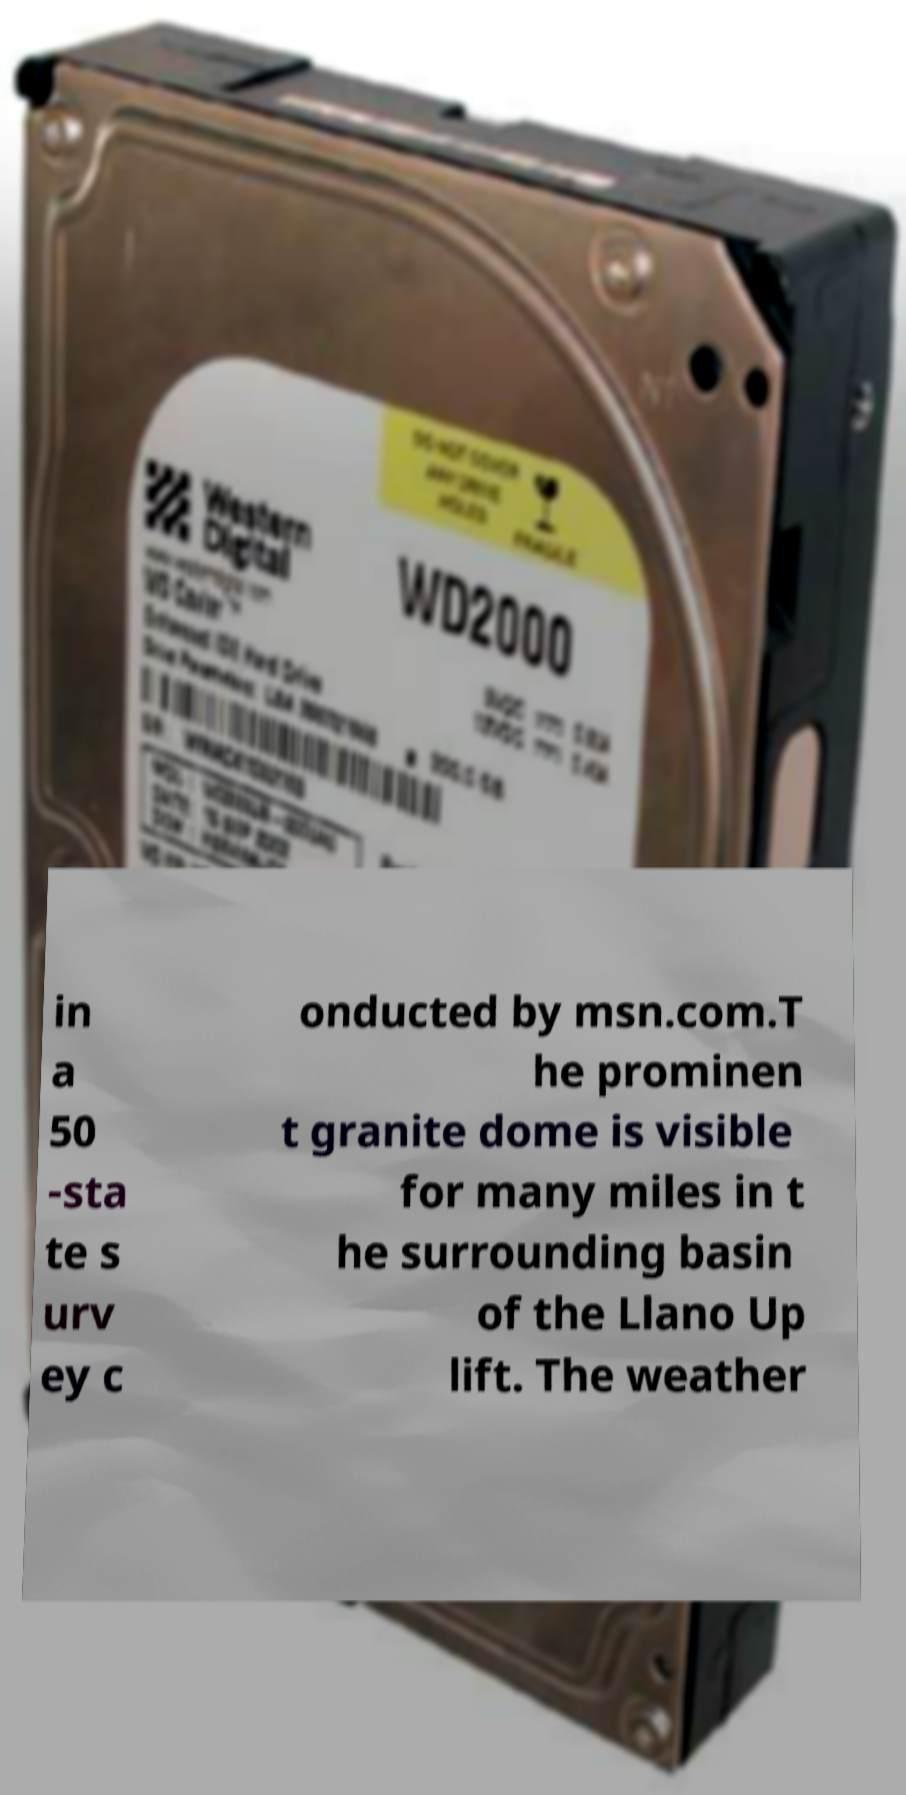For documentation purposes, I need the text within this image transcribed. Could you provide that? in a 50 -sta te s urv ey c onducted by msn.com.T he prominen t granite dome is visible for many miles in t he surrounding basin of the Llano Up lift. The weather 